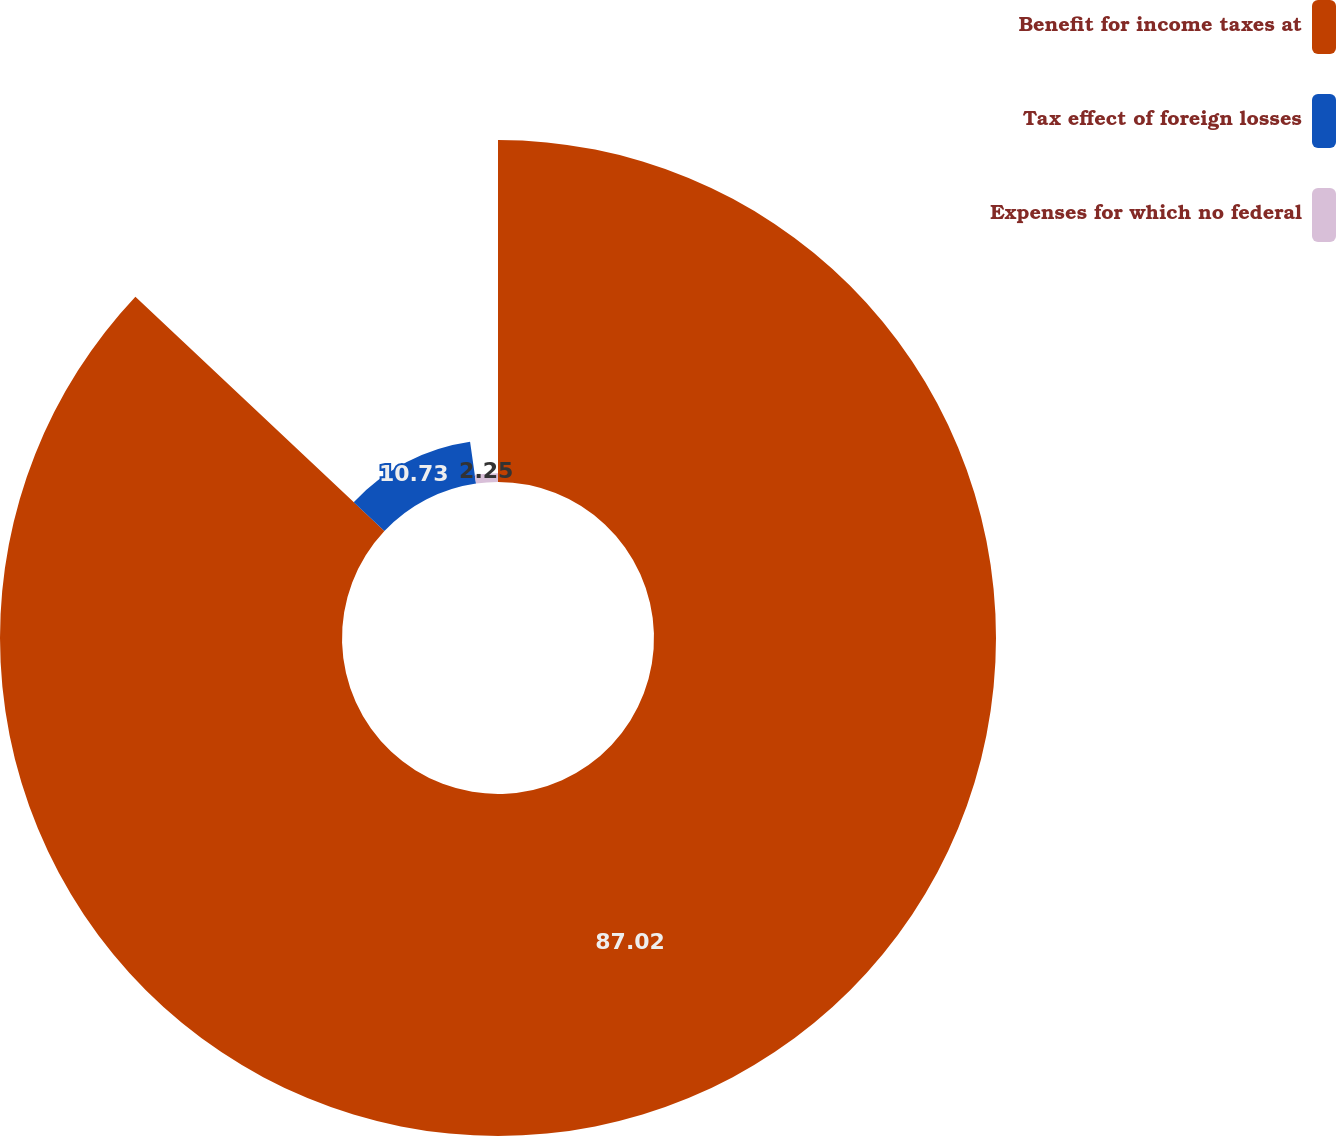<chart> <loc_0><loc_0><loc_500><loc_500><pie_chart><fcel>Benefit for income taxes at<fcel>Tax effect of foreign losses<fcel>Expenses for which no federal<nl><fcel>87.02%<fcel>10.73%<fcel>2.25%<nl></chart> 